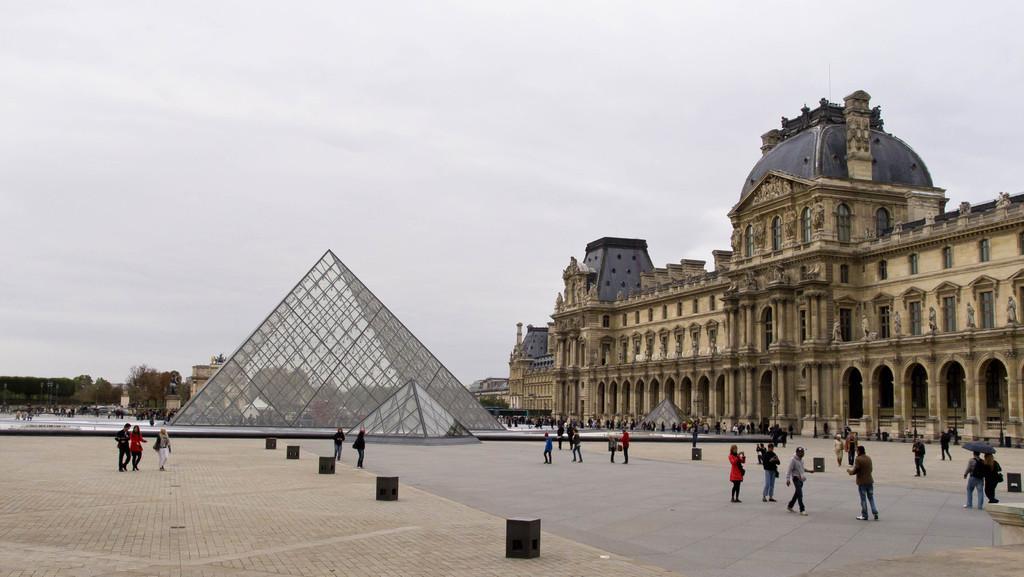Describe this image in one or two sentences. In this picture we can see a building on the right side, there are some people standing here, we can see a glass pyramid here, in the background there are some trees, we can see the sky at the top of the picture, there is a pole here, some of these people are walking. 